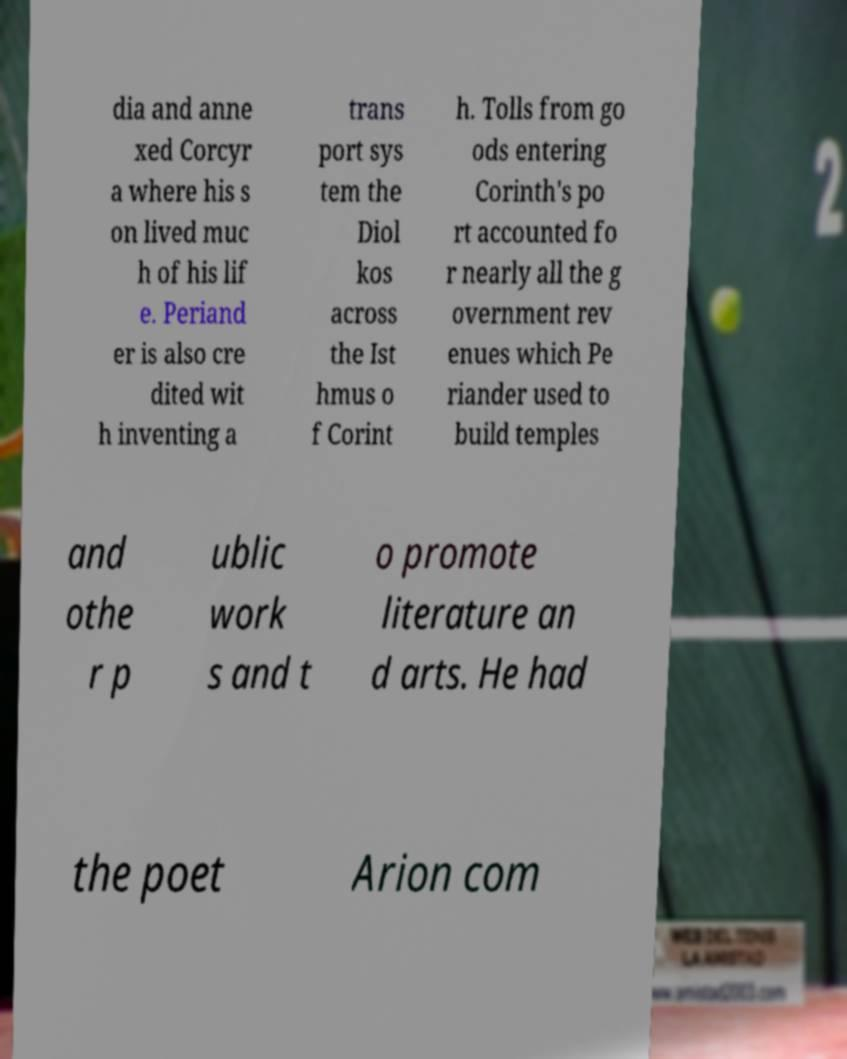Can you accurately transcribe the text from the provided image for me? dia and anne xed Corcyr a where his s on lived muc h of his lif e. Periand er is also cre dited wit h inventing a trans port sys tem the Diol kos across the Ist hmus o f Corint h. Tolls from go ods entering Corinth's po rt accounted fo r nearly all the g overnment rev enues which Pe riander used to build temples and othe r p ublic work s and t o promote literature an d arts. He had the poet Arion com 